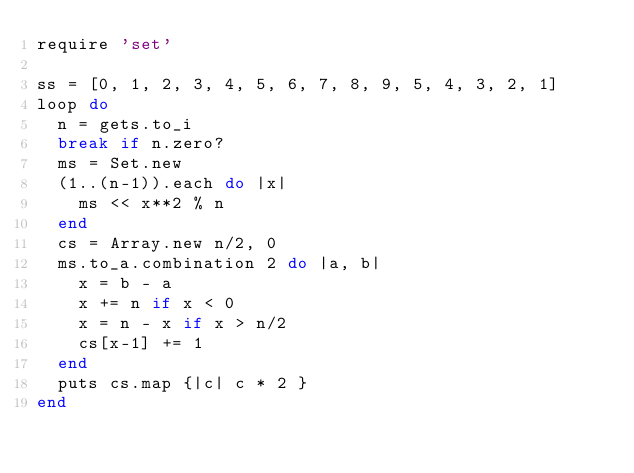Convert code to text. <code><loc_0><loc_0><loc_500><loc_500><_Ruby_>require 'set'

ss = [0, 1, 2, 3, 4, 5, 6, 7, 8, 9, 5, 4, 3, 2, 1]
loop do
  n = gets.to_i
  break if n.zero?
  ms = Set.new
  (1..(n-1)).each do |x|
    ms << x**2 % n
  end
  cs = Array.new n/2, 0
  ms.to_a.combination 2 do |a, b|
    x = b - a
    x += n if x < 0
    x = n - x if x > n/2
    cs[x-1] += 1
  end
  puts cs.map {|c| c * 2 }
end</code> 